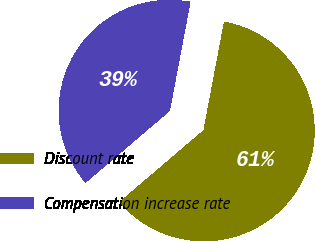Convert chart. <chart><loc_0><loc_0><loc_500><loc_500><pie_chart><fcel>Discount rate<fcel>Compensation increase rate<nl><fcel>60.78%<fcel>39.22%<nl></chart> 